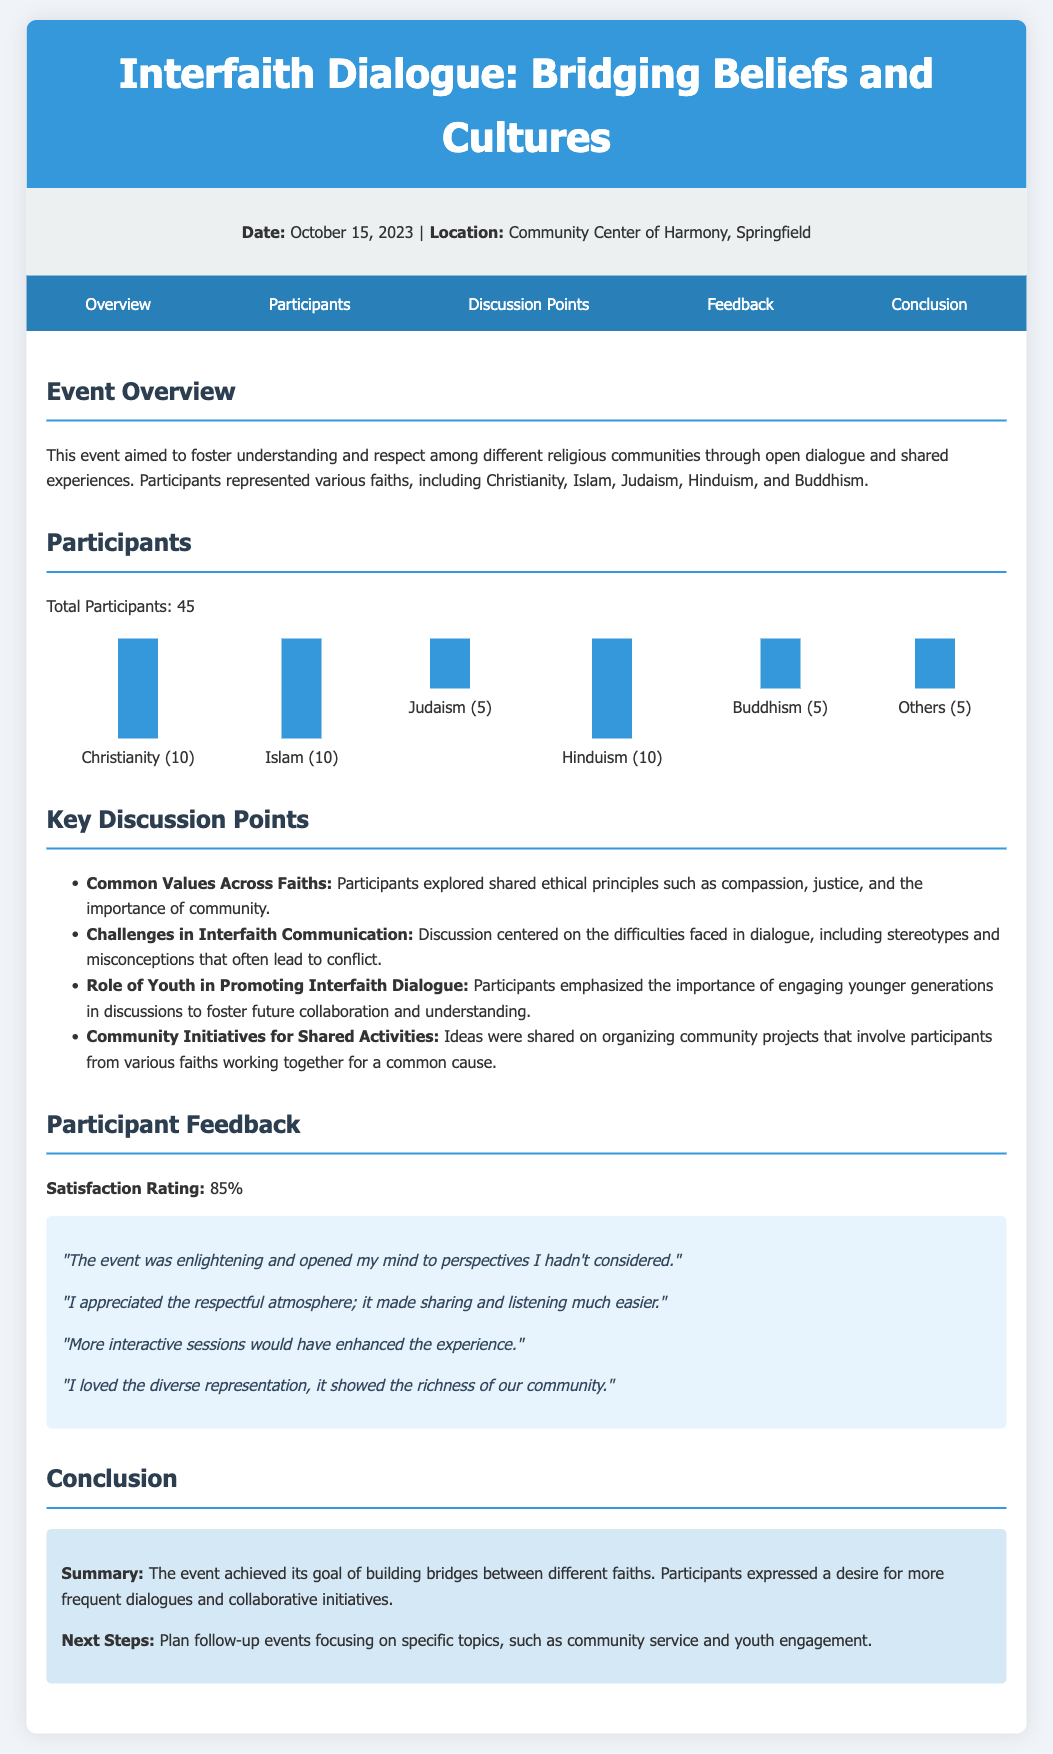What was the date of the event? The date is clearly stated in the event details section of the document.
Answer: October 15, 2023 How many participants were there? The total number of participants is indicated in the participants section.
Answer: 45 Which faith had the most participants? The number of participants from different faiths is listed in the participants chart.
Answer: Christianity What was the satisfaction rating from participants? The satisfaction rating is shown under the participant feedback section.
Answer: 85% What are some common values discussed among participants? The discussion points outline the key themes of the conversation, including shared ethical principles.
Answer: Compassion, justice, and the importance of community What was a suggested next step after the event? The conclusion section lists future actions that were proposed following the event.
Answer: Plan follow-up events What feedback did participants give about the atmosphere of the event? Participant comments provide insights into their experiences, particularly regarding the environment during discussions.
Answer: Respectful atmosphere What was a challenge mentioned in interfaith communication? The document highlights specific difficulties faced in dialogue as discussed by participants.
Answer: Stereotypes and misconceptions 